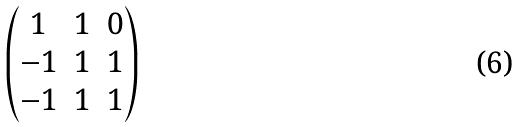<formula> <loc_0><loc_0><loc_500><loc_500>\begin{pmatrix} 1 & 1 & 0 \\ - 1 & 1 & 1 \\ - 1 & 1 & 1 \end{pmatrix}</formula> 